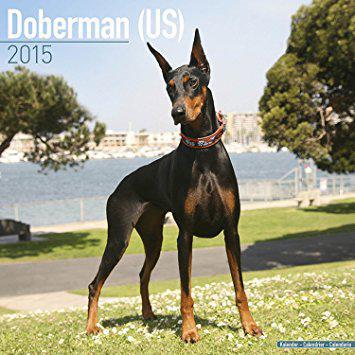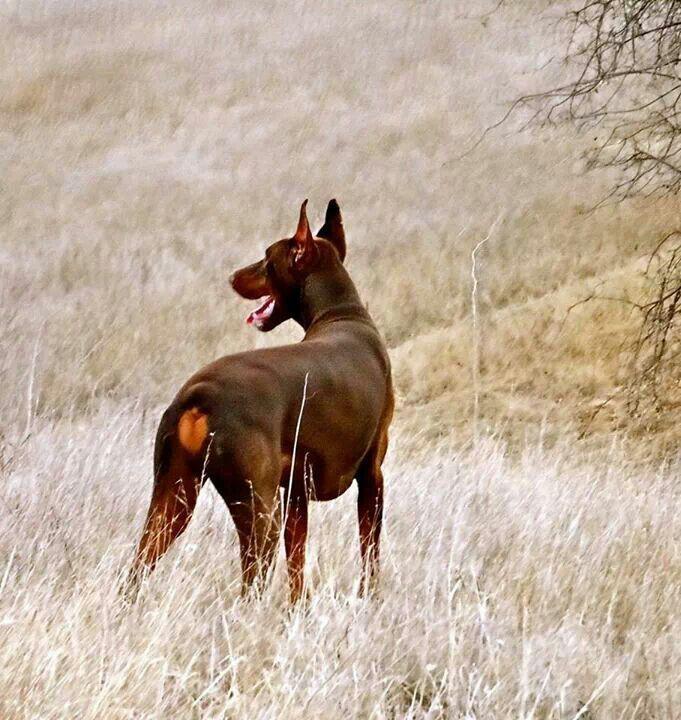The first image is the image on the left, the second image is the image on the right. Examine the images to the left and right. Is the description "There are two or more dogs standing in the left image and laying down in the right." accurate? Answer yes or no. No. The first image is the image on the left, the second image is the image on the right. Analyze the images presented: Is the assertion "The left image contains at least two dogs." valid? Answer yes or no. No. 